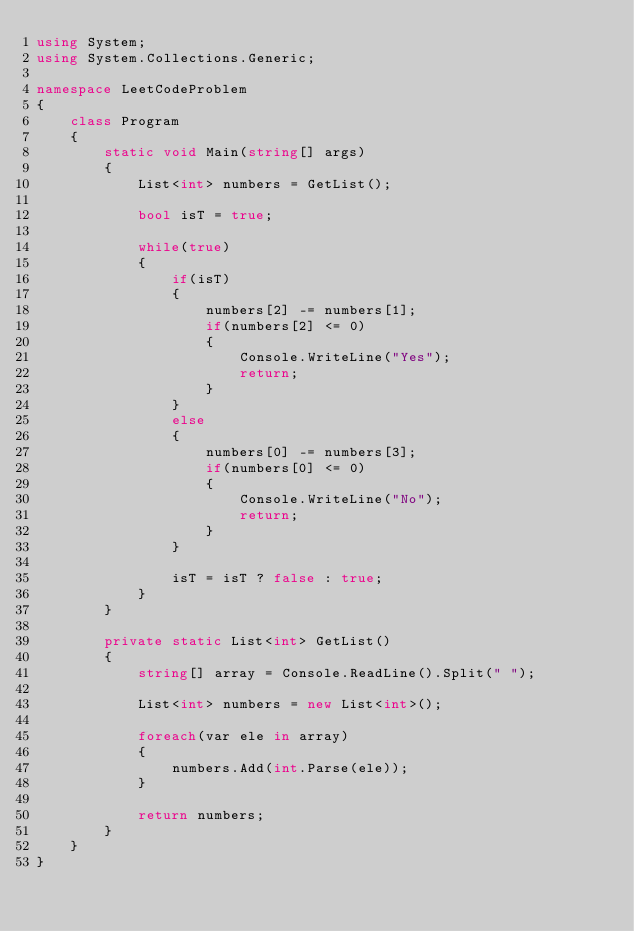<code> <loc_0><loc_0><loc_500><loc_500><_C#_>using System;
using System.Collections.Generic;

namespace LeetCodeProblem
{
    class Program
    {
        static void Main(string[] args)
        {
            List<int> numbers = GetList();

            bool isT = true;

            while(true)
            {
                if(isT)
                {
                    numbers[2] -= numbers[1];
                    if(numbers[2] <= 0)
                    {
                        Console.WriteLine("Yes");
                        return;
                    }
                }
                else
                {
                    numbers[0] -= numbers[3];
                    if(numbers[0] <= 0)
                    {
                        Console.WriteLine("No");
                        return;
                    }
                }

                isT = isT ? false : true;
            }
        }

        private static List<int> GetList()
        {
            string[] array = Console.ReadLine().Split(" ");

            List<int> numbers = new List<int>();

            foreach(var ele in array)
            {
                numbers.Add(int.Parse(ele));
            }

            return numbers;
        }
    }
}
</code> 